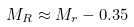<formula> <loc_0><loc_0><loc_500><loc_500>M _ { R } \approx M _ { r } - 0 . 3 5</formula> 